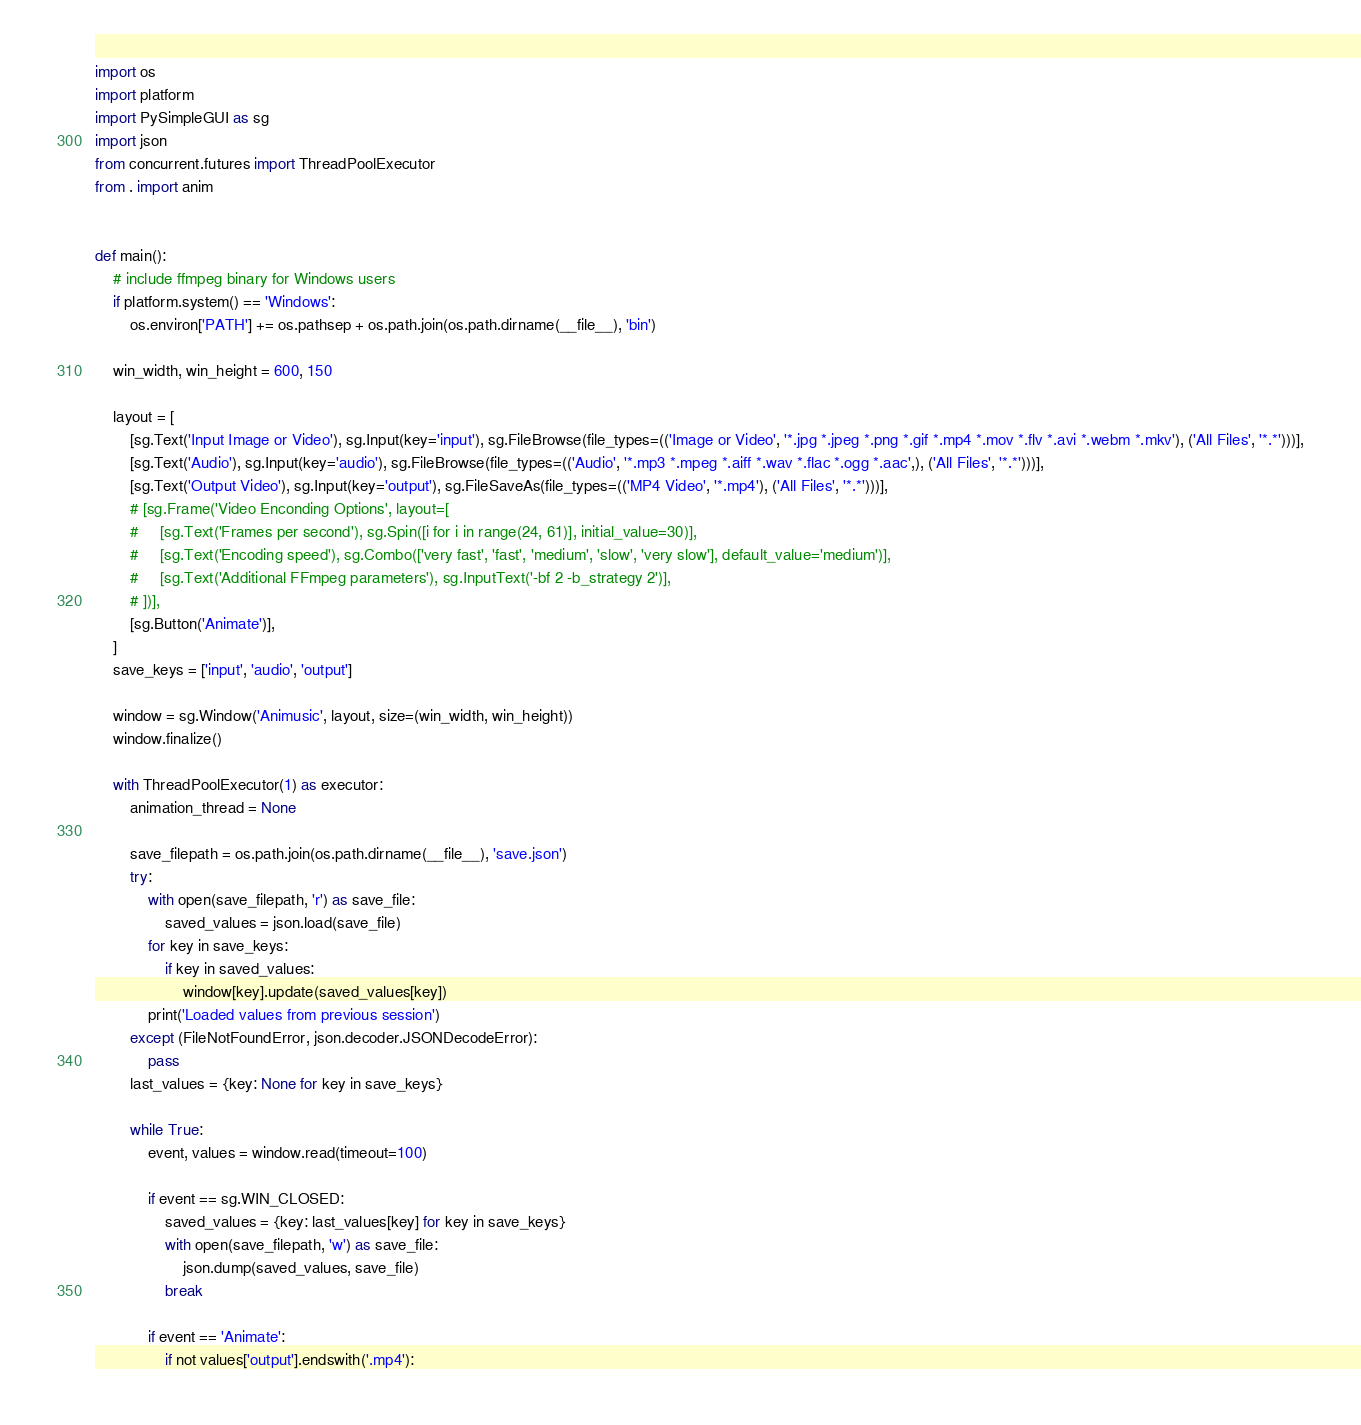<code> <loc_0><loc_0><loc_500><loc_500><_Python_>import os
import platform
import PySimpleGUI as sg
import json
from concurrent.futures import ThreadPoolExecutor
from . import anim


def main():
    # include ffmpeg binary for Windows users
    if platform.system() == 'Windows':
        os.environ['PATH'] += os.pathsep + os.path.join(os.path.dirname(__file__), 'bin')

    win_width, win_height = 600, 150

    layout = [
        [sg.Text('Input Image or Video'), sg.Input(key='input'), sg.FileBrowse(file_types=(('Image or Video', '*.jpg *.jpeg *.png *.gif *.mp4 *.mov *.flv *.avi *.webm *.mkv'), ('All Files', '*.*')))],
        [sg.Text('Audio'), sg.Input(key='audio'), sg.FileBrowse(file_types=(('Audio', '*.mp3 *.mpeg *.aiff *.wav *.flac *.ogg *.aac',), ('All Files', '*.*')))],
        [sg.Text('Output Video'), sg.Input(key='output'), sg.FileSaveAs(file_types=(('MP4 Video', '*.mp4'), ('All Files', '*.*')))],
        # [sg.Frame('Video Enconding Options', layout=[
        #     [sg.Text('Frames per second'), sg.Spin([i for i in range(24, 61)], initial_value=30)],
        #     [sg.Text('Encoding speed'), sg.Combo(['very fast', 'fast', 'medium', 'slow', 'very slow'], default_value='medium')],
        #     [sg.Text('Additional FFmpeg parameters'), sg.InputText('-bf 2 -b_strategy 2')],
        # ])],
        [sg.Button('Animate')],
    ]
    save_keys = ['input', 'audio', 'output']

    window = sg.Window('Animusic', layout, size=(win_width, win_height))
    window.finalize()
    
    with ThreadPoolExecutor(1) as executor:
        animation_thread = None

        save_filepath = os.path.join(os.path.dirname(__file__), 'save.json')
        try:
            with open(save_filepath, 'r') as save_file:
                saved_values = json.load(save_file)
            for key in save_keys:
                if key in saved_values:
                    window[key].update(saved_values[key])
            print('Loaded values from previous session')
        except (FileNotFoundError, json.decoder.JSONDecodeError):
            pass
        last_values = {key: None for key in save_keys}

        while True:
            event, values = window.read(timeout=100)

            if event == sg.WIN_CLOSED:
                saved_values = {key: last_values[key] for key in save_keys}
                with open(save_filepath, 'w') as save_file:
                    json.dump(saved_values, save_file)
                break

            if event == 'Animate':
                if not values['output'].endswith('.mp4'):</code> 